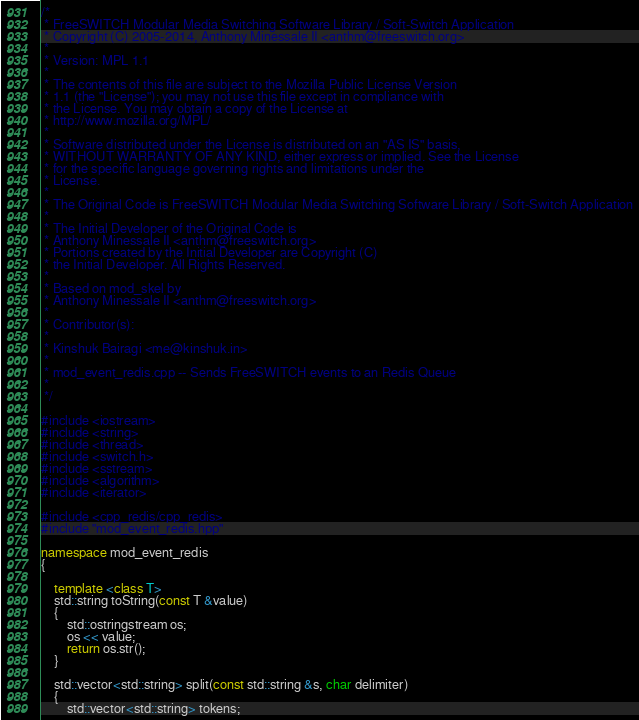<code> <loc_0><loc_0><loc_500><loc_500><_C++_>/*
 * FreeSWITCH Modular Media Switching Software Library / Soft-Switch Application
 * Copyright (C) 2005-2014, Anthony Minessale II <anthm@freeswitch.org>
 *
 * Version: MPL 1.1
 *
 * The contents of this file are subject to the Mozilla Public License Version
 * 1.1 (the "License"); you may not use this file except in compliance with
 * the License. You may obtain a copy of the License at
 * http://www.mozilla.org/MPL/
 *
 * Software distributed under the License is distributed on an "AS IS" basis,
 * WITHOUT WARRANTY OF ANY KIND, either express or implied. See the License
 * for the specific language governing rights and limitations under the
 * License.
 *
 * The Original Code is FreeSWITCH Modular Media Switching Software Library / Soft-Switch Application
 *
 * The Initial Developer of the Original Code is
 * Anthony Minessale II <anthm@freeswitch.org>
 * Portions created by the Initial Developer are Copyright (C)
 * the Initial Developer. All Rights Reserved.
 *
 * Based on mod_skel by
 * Anthony Minessale II <anthm@freeswitch.org>
 *
 * Contributor(s):
 * 
 * Kinshuk Bairagi <me@kinshuk.in>
 *
 * mod_event_redis.cpp -- Sends FreeSWITCH events to an Redis Queue
 *
 */

#include <iostream>
#include <string>
#include <thread>
#include <switch.h>
#include <sstream>
#include <algorithm>
#include <iterator>

#include <cpp_redis/cpp_redis>
#include "mod_event_redis.hpp"

namespace mod_event_redis
{

    template <class T>
    std::string toString(const T &value)
    {
        std::ostringstream os;
        os << value;
        return os.str();
    }

    std::vector<std::string> split(const std::string &s, char delimiter)
    {
        std::vector<std::string> tokens;</code> 